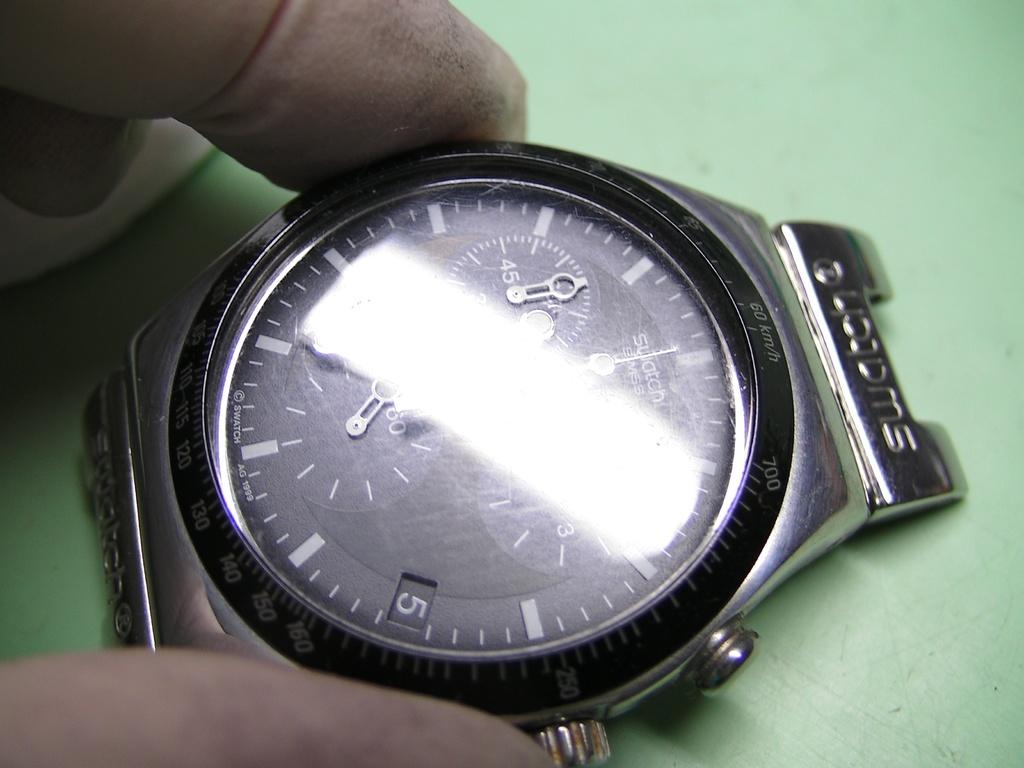What is the brand of this watch?
Make the answer very short. Swatch. What is the date of the month according to the watch?
Make the answer very short. 5. 